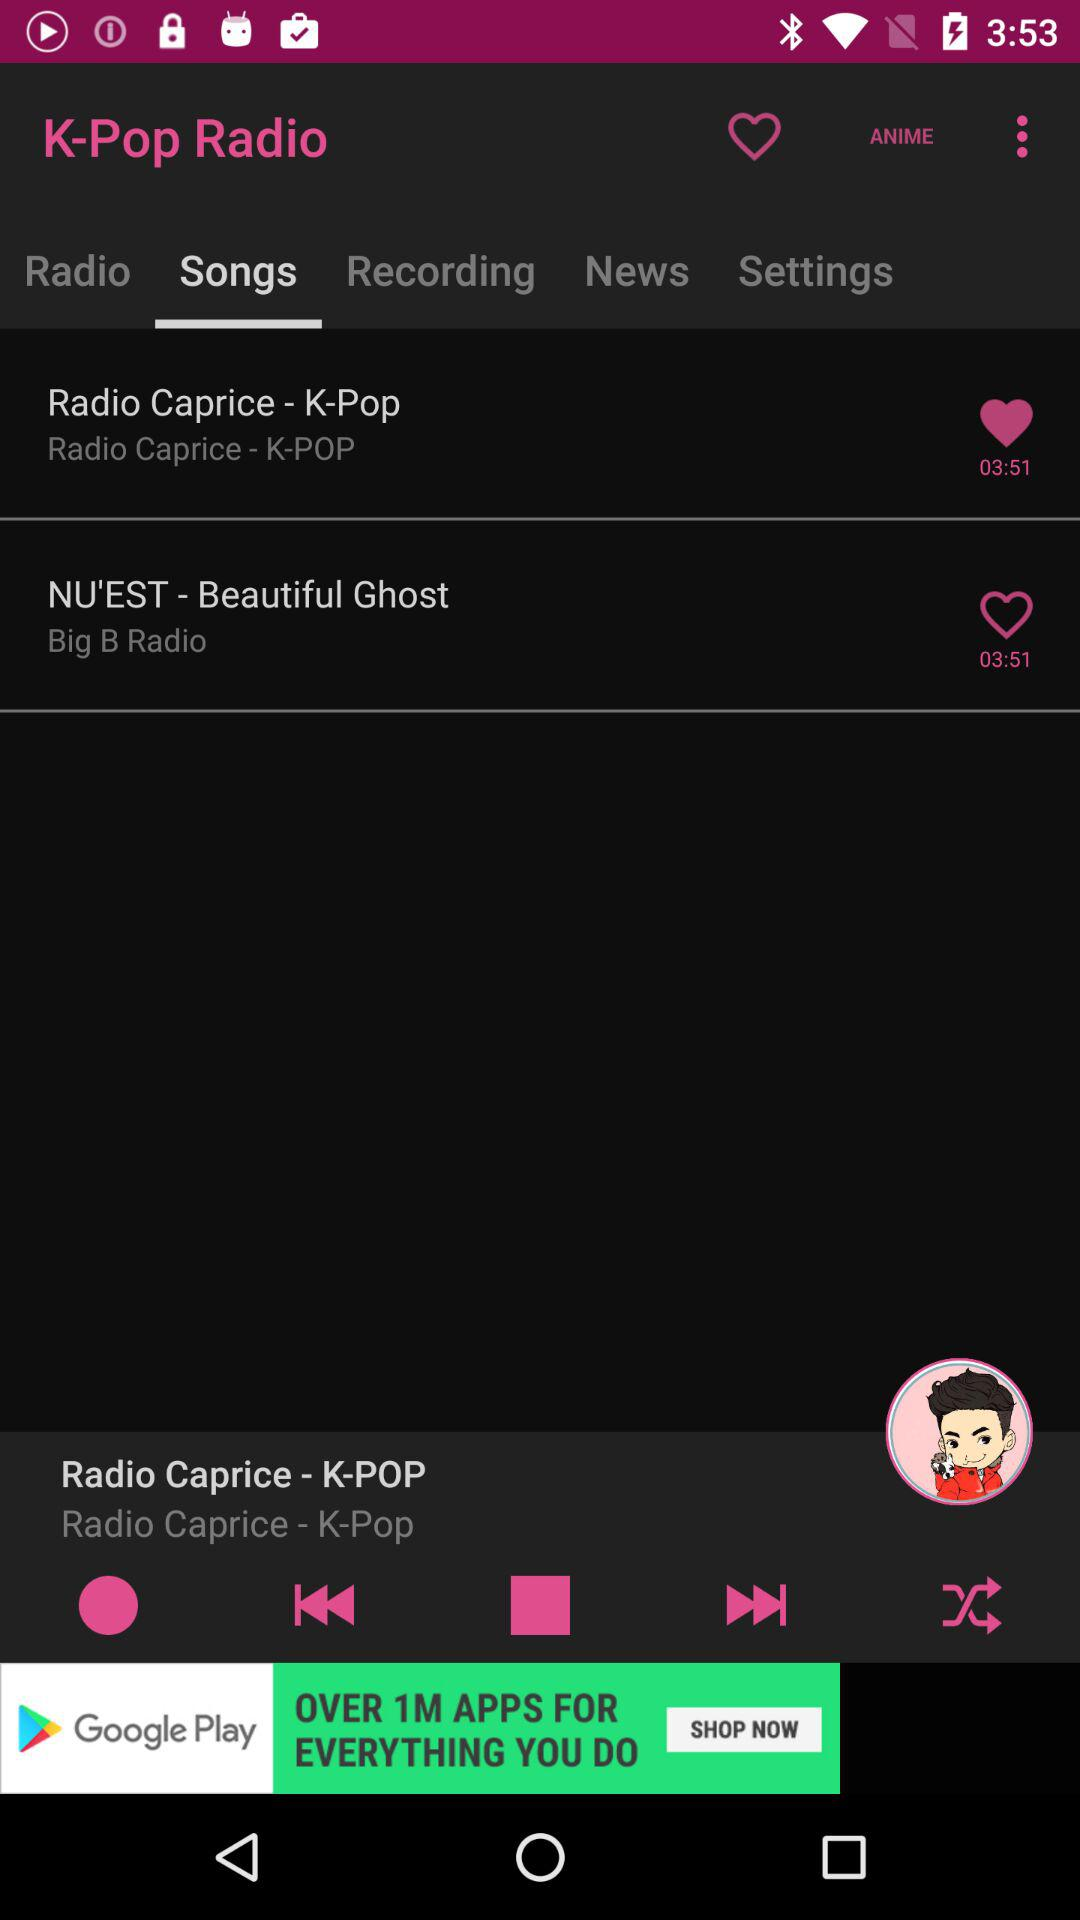Which song is playing? The song playing is "Radio Caprice - K-POP". 